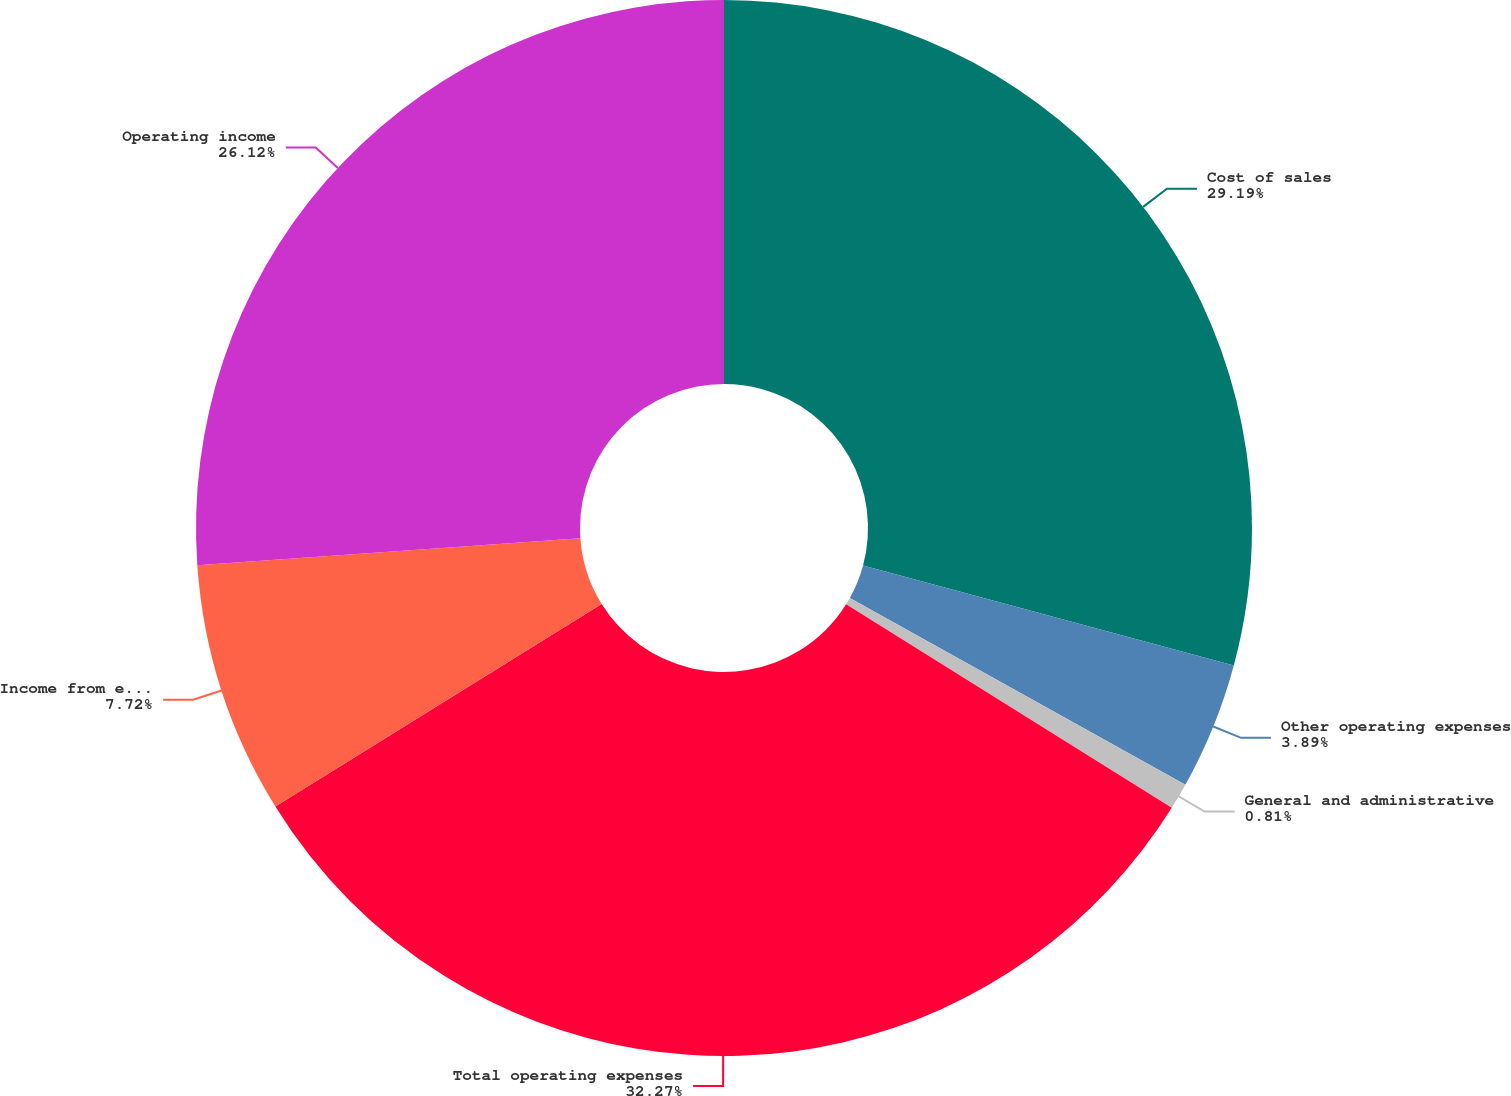<chart> <loc_0><loc_0><loc_500><loc_500><pie_chart><fcel>Cost of sales<fcel>Other operating expenses<fcel>General and administrative<fcel>Total operating expenses<fcel>Income from equity investees<fcel>Operating income<nl><fcel>29.19%<fcel>3.89%<fcel>0.81%<fcel>32.27%<fcel>7.72%<fcel>26.12%<nl></chart> 